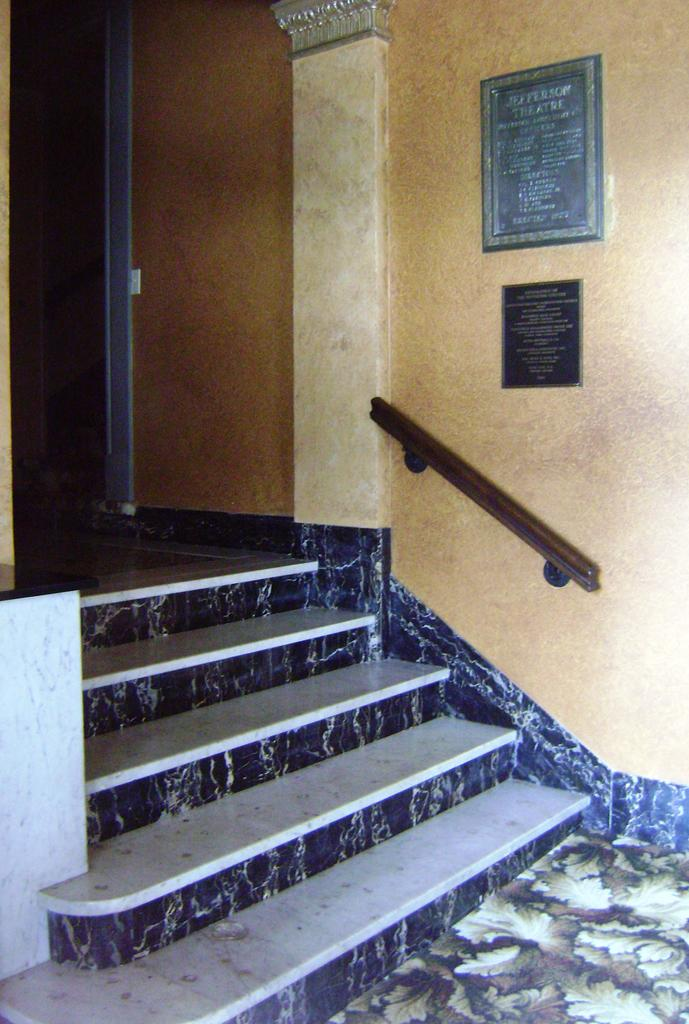What type of architectural feature is present in the image? There are stairs in the image. What other structural elements can be seen in the image? There are walls and a floor in the image. What material is the wooden object made of? The wooden object in the image is made of wood. What is hanging on the walls in the image? There are frames on the wall in the image. What direction does the person wave good-bye in the image? There is no person waving good-bye in the image. What part of the body is the person using to side-step in the image? There is no person side-stepping or performing any action in the image. 